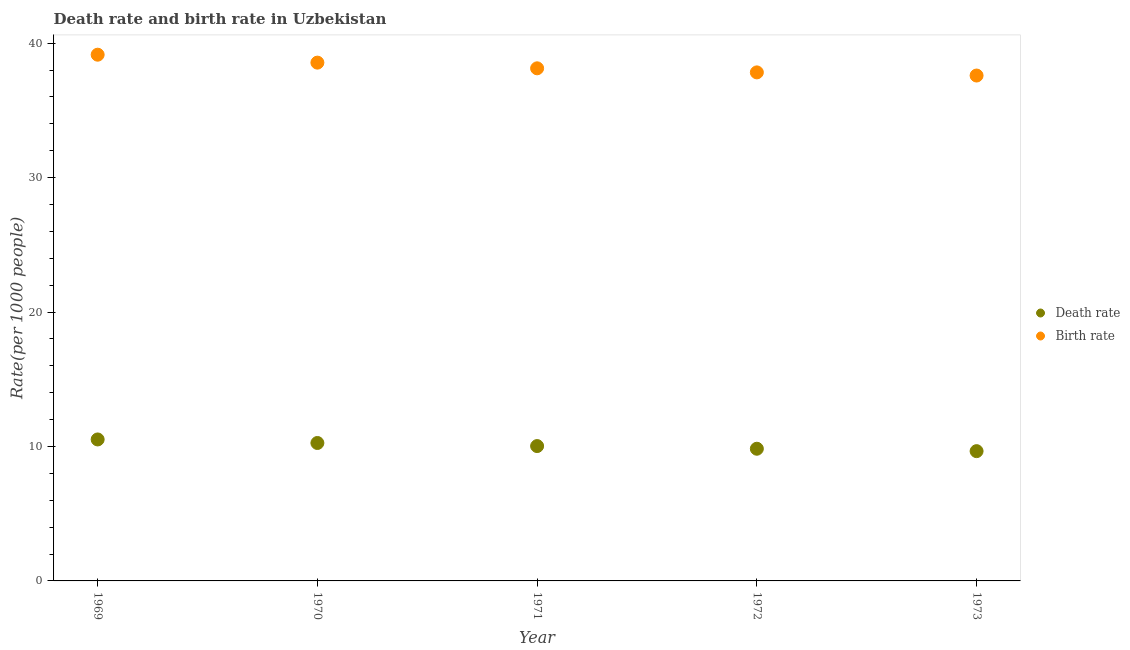How many different coloured dotlines are there?
Offer a very short reply. 2. What is the birth rate in 1972?
Provide a short and direct response. 37.83. Across all years, what is the maximum death rate?
Your answer should be compact. 10.52. Across all years, what is the minimum birth rate?
Ensure brevity in your answer.  37.6. In which year was the birth rate maximum?
Your response must be concise. 1969. In which year was the birth rate minimum?
Ensure brevity in your answer.  1973. What is the total death rate in the graph?
Offer a very short reply. 50.3. What is the difference between the death rate in 1969 and that in 1972?
Provide a succinct answer. 0.69. What is the difference between the death rate in 1972 and the birth rate in 1973?
Your answer should be compact. -27.76. What is the average birth rate per year?
Provide a short and direct response. 38.25. In the year 1971, what is the difference between the birth rate and death rate?
Keep it short and to the point. 28.1. In how many years, is the birth rate greater than 10?
Offer a very short reply. 5. What is the ratio of the death rate in 1972 to that in 1973?
Keep it short and to the point. 1.02. What is the difference between the highest and the second highest death rate?
Give a very brief answer. 0.26. What is the difference between the highest and the lowest death rate?
Provide a succinct answer. 0.87. Is the death rate strictly greater than the birth rate over the years?
Ensure brevity in your answer.  No. Is the birth rate strictly less than the death rate over the years?
Ensure brevity in your answer.  No. How many dotlines are there?
Your response must be concise. 2. What is the difference between two consecutive major ticks on the Y-axis?
Your response must be concise. 10. Does the graph contain any zero values?
Offer a terse response. No. Where does the legend appear in the graph?
Your answer should be compact. Center right. How many legend labels are there?
Offer a terse response. 2. How are the legend labels stacked?
Your response must be concise. Vertical. What is the title of the graph?
Ensure brevity in your answer.  Death rate and birth rate in Uzbekistan. What is the label or title of the X-axis?
Provide a succinct answer. Year. What is the label or title of the Y-axis?
Provide a succinct answer. Rate(per 1000 people). What is the Rate(per 1000 people) of Death rate in 1969?
Offer a very short reply. 10.52. What is the Rate(per 1000 people) in Birth rate in 1969?
Your answer should be very brief. 39.15. What is the Rate(per 1000 people) of Death rate in 1970?
Provide a short and direct response. 10.26. What is the Rate(per 1000 people) in Birth rate in 1970?
Keep it short and to the point. 38.56. What is the Rate(per 1000 people) in Death rate in 1971?
Give a very brief answer. 10.03. What is the Rate(per 1000 people) in Birth rate in 1971?
Offer a terse response. 38.13. What is the Rate(per 1000 people) of Death rate in 1972?
Keep it short and to the point. 9.83. What is the Rate(per 1000 people) of Birth rate in 1972?
Offer a very short reply. 37.83. What is the Rate(per 1000 people) of Death rate in 1973?
Your answer should be compact. 9.65. What is the Rate(per 1000 people) of Birth rate in 1973?
Offer a very short reply. 37.6. Across all years, what is the maximum Rate(per 1000 people) in Death rate?
Provide a short and direct response. 10.52. Across all years, what is the maximum Rate(per 1000 people) in Birth rate?
Offer a very short reply. 39.15. Across all years, what is the minimum Rate(per 1000 people) of Death rate?
Keep it short and to the point. 9.65. Across all years, what is the minimum Rate(per 1000 people) in Birth rate?
Ensure brevity in your answer.  37.6. What is the total Rate(per 1000 people) of Death rate in the graph?
Provide a short and direct response. 50.3. What is the total Rate(per 1000 people) of Birth rate in the graph?
Offer a very short reply. 191.26. What is the difference between the Rate(per 1000 people) of Death rate in 1969 and that in 1970?
Ensure brevity in your answer.  0.26. What is the difference between the Rate(per 1000 people) in Birth rate in 1969 and that in 1970?
Keep it short and to the point. 0.59. What is the difference between the Rate(per 1000 people) in Death rate in 1969 and that in 1971?
Offer a very short reply. 0.49. What is the difference between the Rate(per 1000 people) of Death rate in 1969 and that in 1972?
Ensure brevity in your answer.  0.69. What is the difference between the Rate(per 1000 people) of Birth rate in 1969 and that in 1972?
Your response must be concise. 1.32. What is the difference between the Rate(per 1000 people) in Death rate in 1969 and that in 1973?
Your answer should be very brief. 0.87. What is the difference between the Rate(per 1000 people) of Birth rate in 1969 and that in 1973?
Keep it short and to the point. 1.55. What is the difference between the Rate(per 1000 people) in Death rate in 1970 and that in 1971?
Offer a terse response. 0.23. What is the difference between the Rate(per 1000 people) in Birth rate in 1970 and that in 1971?
Your response must be concise. 0.42. What is the difference between the Rate(per 1000 people) of Death rate in 1970 and that in 1972?
Keep it short and to the point. 0.43. What is the difference between the Rate(per 1000 people) of Birth rate in 1970 and that in 1972?
Your answer should be compact. 0.73. What is the difference between the Rate(per 1000 people) of Death rate in 1970 and that in 1973?
Your answer should be very brief. 0.61. What is the difference between the Rate(per 1000 people) in Birth rate in 1970 and that in 1973?
Offer a terse response. 0.96. What is the difference between the Rate(per 1000 people) in Death rate in 1971 and that in 1972?
Provide a short and direct response. 0.2. What is the difference between the Rate(per 1000 people) of Birth rate in 1971 and that in 1972?
Make the answer very short. 0.3. What is the difference between the Rate(per 1000 people) in Death rate in 1971 and that in 1973?
Give a very brief answer. 0.38. What is the difference between the Rate(per 1000 people) in Birth rate in 1971 and that in 1973?
Make the answer very short. 0.54. What is the difference between the Rate(per 1000 people) in Death rate in 1972 and that in 1973?
Offer a very short reply. 0.18. What is the difference between the Rate(per 1000 people) in Birth rate in 1972 and that in 1973?
Your response must be concise. 0.23. What is the difference between the Rate(per 1000 people) of Death rate in 1969 and the Rate(per 1000 people) of Birth rate in 1970?
Provide a short and direct response. -28.03. What is the difference between the Rate(per 1000 people) of Death rate in 1969 and the Rate(per 1000 people) of Birth rate in 1971?
Provide a succinct answer. -27.61. What is the difference between the Rate(per 1000 people) in Death rate in 1969 and the Rate(per 1000 people) in Birth rate in 1972?
Offer a terse response. -27.31. What is the difference between the Rate(per 1000 people) of Death rate in 1969 and the Rate(per 1000 people) of Birth rate in 1973?
Ensure brevity in your answer.  -27.07. What is the difference between the Rate(per 1000 people) of Death rate in 1970 and the Rate(per 1000 people) of Birth rate in 1971?
Your answer should be compact. -27.87. What is the difference between the Rate(per 1000 people) of Death rate in 1970 and the Rate(per 1000 people) of Birth rate in 1972?
Provide a short and direct response. -27.57. What is the difference between the Rate(per 1000 people) in Death rate in 1970 and the Rate(per 1000 people) in Birth rate in 1973?
Keep it short and to the point. -27.34. What is the difference between the Rate(per 1000 people) of Death rate in 1971 and the Rate(per 1000 people) of Birth rate in 1972?
Your answer should be very brief. -27.8. What is the difference between the Rate(per 1000 people) in Death rate in 1971 and the Rate(per 1000 people) in Birth rate in 1973?
Offer a terse response. -27.56. What is the difference between the Rate(per 1000 people) of Death rate in 1972 and the Rate(per 1000 people) of Birth rate in 1973?
Your answer should be very brief. -27.76. What is the average Rate(per 1000 people) of Death rate per year?
Keep it short and to the point. 10.06. What is the average Rate(per 1000 people) in Birth rate per year?
Your answer should be very brief. 38.25. In the year 1969, what is the difference between the Rate(per 1000 people) in Death rate and Rate(per 1000 people) in Birth rate?
Provide a short and direct response. -28.62. In the year 1970, what is the difference between the Rate(per 1000 people) in Death rate and Rate(per 1000 people) in Birth rate?
Keep it short and to the point. -28.3. In the year 1971, what is the difference between the Rate(per 1000 people) of Death rate and Rate(per 1000 people) of Birth rate?
Give a very brief answer. -28.1. In the year 1972, what is the difference between the Rate(per 1000 people) of Death rate and Rate(per 1000 people) of Birth rate?
Provide a short and direct response. -28. In the year 1973, what is the difference between the Rate(per 1000 people) in Death rate and Rate(per 1000 people) in Birth rate?
Provide a short and direct response. -27.94. What is the ratio of the Rate(per 1000 people) of Death rate in 1969 to that in 1970?
Provide a short and direct response. 1.03. What is the ratio of the Rate(per 1000 people) in Birth rate in 1969 to that in 1970?
Make the answer very short. 1.02. What is the ratio of the Rate(per 1000 people) in Death rate in 1969 to that in 1971?
Make the answer very short. 1.05. What is the ratio of the Rate(per 1000 people) in Birth rate in 1969 to that in 1971?
Offer a very short reply. 1.03. What is the ratio of the Rate(per 1000 people) of Death rate in 1969 to that in 1972?
Make the answer very short. 1.07. What is the ratio of the Rate(per 1000 people) of Birth rate in 1969 to that in 1972?
Ensure brevity in your answer.  1.03. What is the ratio of the Rate(per 1000 people) in Death rate in 1969 to that in 1973?
Your answer should be very brief. 1.09. What is the ratio of the Rate(per 1000 people) of Birth rate in 1969 to that in 1973?
Give a very brief answer. 1.04. What is the ratio of the Rate(per 1000 people) of Death rate in 1970 to that in 1971?
Offer a terse response. 1.02. What is the ratio of the Rate(per 1000 people) in Birth rate in 1970 to that in 1971?
Your answer should be very brief. 1.01. What is the ratio of the Rate(per 1000 people) in Death rate in 1970 to that in 1972?
Offer a very short reply. 1.04. What is the ratio of the Rate(per 1000 people) in Birth rate in 1970 to that in 1972?
Your response must be concise. 1.02. What is the ratio of the Rate(per 1000 people) in Death rate in 1970 to that in 1973?
Keep it short and to the point. 1.06. What is the ratio of the Rate(per 1000 people) of Birth rate in 1970 to that in 1973?
Offer a very short reply. 1.03. What is the ratio of the Rate(per 1000 people) of Death rate in 1971 to that in 1972?
Your answer should be very brief. 1.02. What is the ratio of the Rate(per 1000 people) of Death rate in 1971 to that in 1973?
Your answer should be very brief. 1.04. What is the ratio of the Rate(per 1000 people) of Birth rate in 1971 to that in 1973?
Give a very brief answer. 1.01. What is the ratio of the Rate(per 1000 people) in Death rate in 1972 to that in 1973?
Offer a terse response. 1.02. What is the ratio of the Rate(per 1000 people) in Birth rate in 1972 to that in 1973?
Make the answer very short. 1.01. What is the difference between the highest and the second highest Rate(per 1000 people) in Death rate?
Give a very brief answer. 0.26. What is the difference between the highest and the second highest Rate(per 1000 people) of Birth rate?
Your answer should be very brief. 0.59. What is the difference between the highest and the lowest Rate(per 1000 people) of Death rate?
Make the answer very short. 0.87. What is the difference between the highest and the lowest Rate(per 1000 people) in Birth rate?
Make the answer very short. 1.55. 